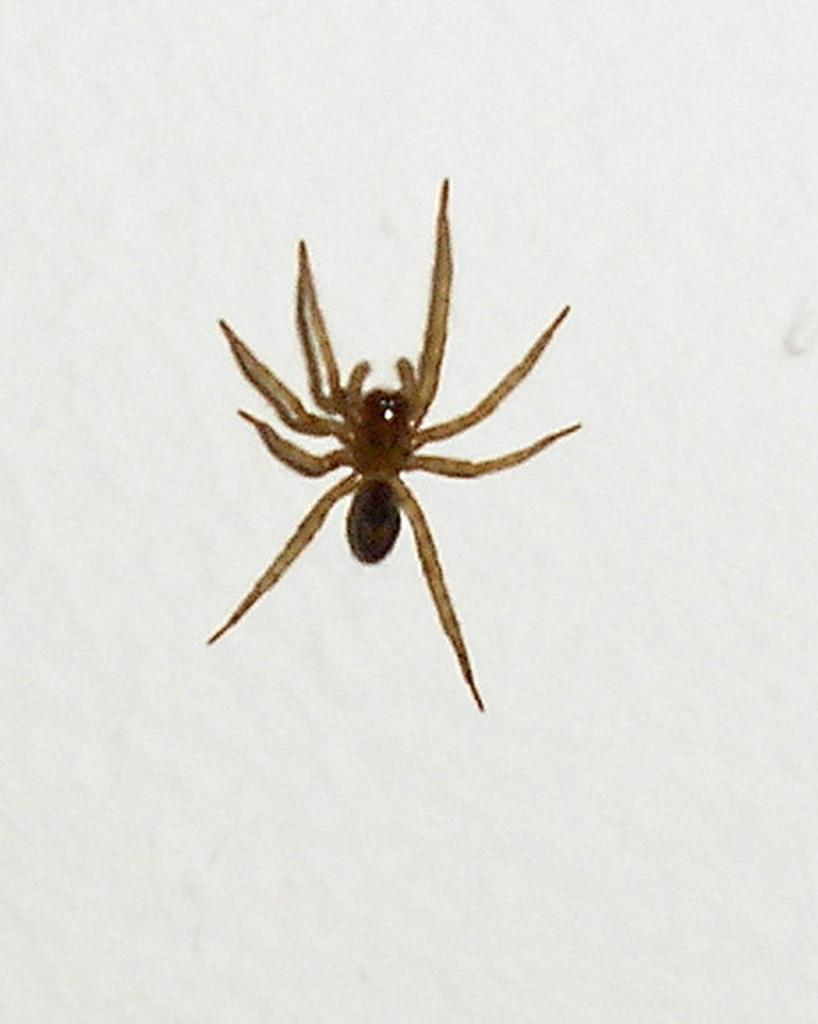What is the main subject of the image? There is a spider in the image. Where is the spider located? The spider is on a surface. What color is the background of the image? The background of the image is white in color. How many snakes are slithering through space in the image? There are no snakes or space present in the image; it features a spider on a surface with a white background. What type of brush is being used to paint the spider in the image? There is no brush or painting activity depicted in the image; it is a photograph or illustration of a spider on a surface. 